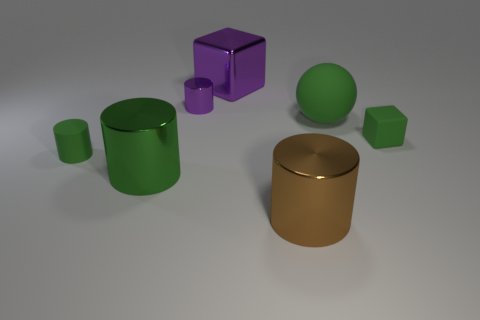Can you describe the shapes and colors of the objects in the image? Certainly! There are six objects in the image with varying shapes and colors. Starting from the left, we have a small green cylinder, a medium green cylinder, and a large green sphere. In the center, there's a small green cube. On the right-hand side, we observe a large purple cube and a large golden cylinder. The background is neutral, providing a soft contrast to the vivid colors of the objects. 